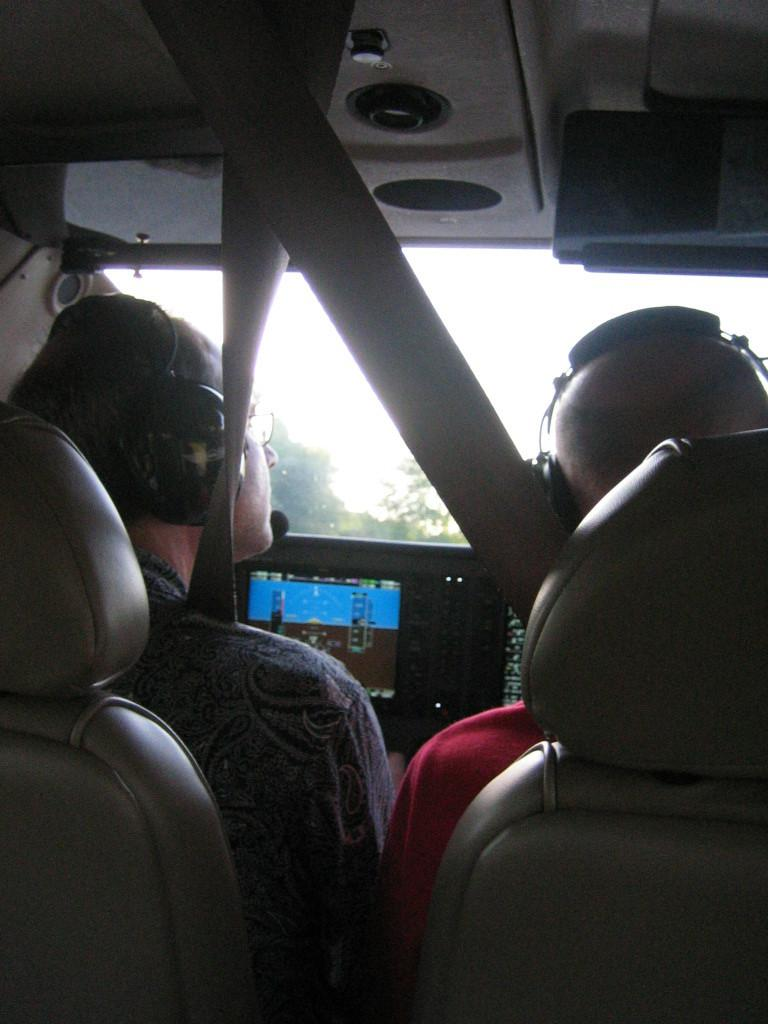How many people are in the image? There are two people in the image. What are the people doing in the image? The people are sitting on seats in the image. Where is the setting of the image? The setting is inside an aircraft. What is in front of the people? There is a screen in front of the people. What can be seen outside the aircraft in the image? Trees are visible in the image. How much does the beggar charge for a ticket in the image? There is no beggar or ticket present in the image. What role does the actor play in the image? There is no actor present in the image. 